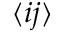<formula> <loc_0><loc_0><loc_500><loc_500>\langle i j \rangle</formula> 